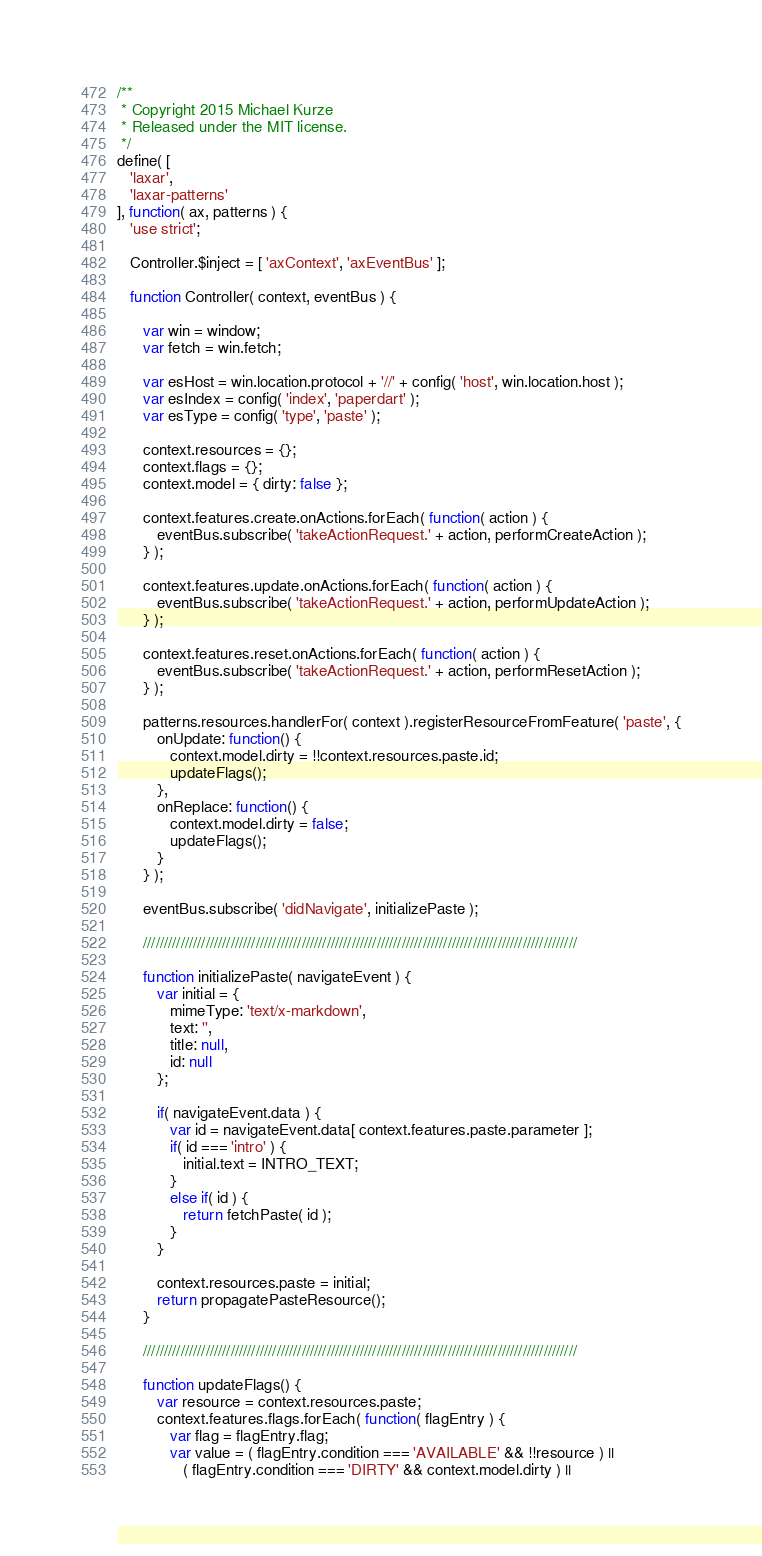Convert code to text. <code><loc_0><loc_0><loc_500><loc_500><_JavaScript_>/**
 * Copyright 2015 Michael Kurze
 * Released under the MIT license.
 */
define( [
   'laxar',
   'laxar-patterns'
], function( ax, patterns ) {
   'use strict';

   Controller.$inject = [ 'axContext', 'axEventBus' ];

   function Controller( context, eventBus ) {

      var win = window;
      var fetch = win.fetch;

      var esHost = win.location.protocol + '//' + config( 'host', win.location.host );
      var esIndex = config( 'index', 'paperdart' );
      var esType = config( 'type', 'paste' );

      context.resources = {};
      context.flags = {};
      context.model = { dirty: false };

      context.features.create.onActions.forEach( function( action ) {
         eventBus.subscribe( 'takeActionRequest.' + action, performCreateAction );
      } );

      context.features.update.onActions.forEach( function( action ) {
         eventBus.subscribe( 'takeActionRequest.' + action, performUpdateAction );
      } );

      context.features.reset.onActions.forEach( function( action ) {
         eventBus.subscribe( 'takeActionRequest.' + action, performResetAction );
      } );

      patterns.resources.handlerFor( context ).registerResourceFromFeature( 'paste', {
         onUpdate: function() {
            context.model.dirty = !!context.resources.paste.id;
            updateFlags();
         },
         onReplace: function() {
            context.model.dirty = false;
            updateFlags();
         }
      } );

      eventBus.subscribe( 'didNavigate', initializePaste );

      ////////////////////////////////////////////////////////////////////////////////////////////////////////

      function initializePaste( navigateEvent ) {
         var initial = {
            mimeType: 'text/x-markdown',
            text: '',
            title: null,
            id: null
         };

         if( navigateEvent.data ) {
            var id = navigateEvent.data[ context.features.paste.parameter ];
            if( id === 'intro' ) {
               initial.text = INTRO_TEXT;
            }
            else if( id ) {
               return fetchPaste( id );
            }
         }

         context.resources.paste = initial;
         return propagatePasteResource();
      }

      ////////////////////////////////////////////////////////////////////////////////////////////////////////

      function updateFlags() {
         var resource = context.resources.paste;
         context.features.flags.forEach( function( flagEntry ) {
            var flag = flagEntry.flag;
            var value = ( flagEntry.condition === 'AVAILABLE' && !!resource ) ||
               ( flagEntry.condition === 'DIRTY' && context.model.dirty ) ||</code> 